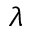Convert formula to latex. <formula><loc_0><loc_0><loc_500><loc_500>\lambda</formula> 